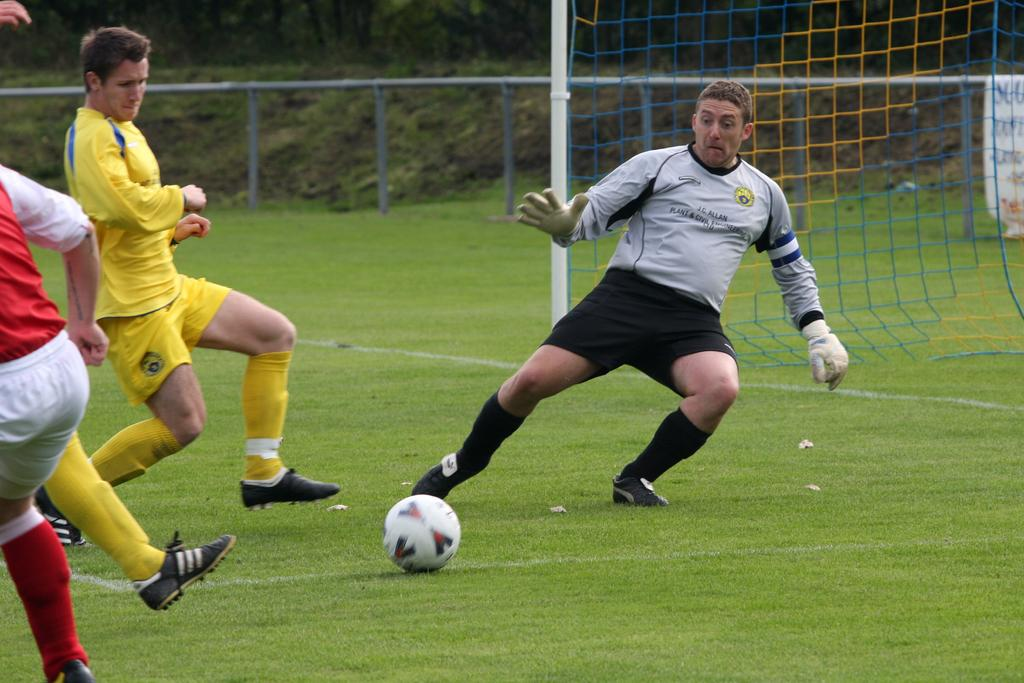What are the two people in the image doing? The two people in the image are playing football. What role does one of the people have in the game? One of the people is acting as a goalkeeper. What action is the goalkeeper taking in the image? The goalkeeper is trying to stop the ball. What can be seen in the background of the image related to the game? There is a goal post visible in the background of the image. What other feature can be seen in the background of the image? There is a fence in the background of the image. How many knots are tied in the alley in the image? There is no alley or knots present in the image; it features two people playing football with a goal post and a fence in the background. 